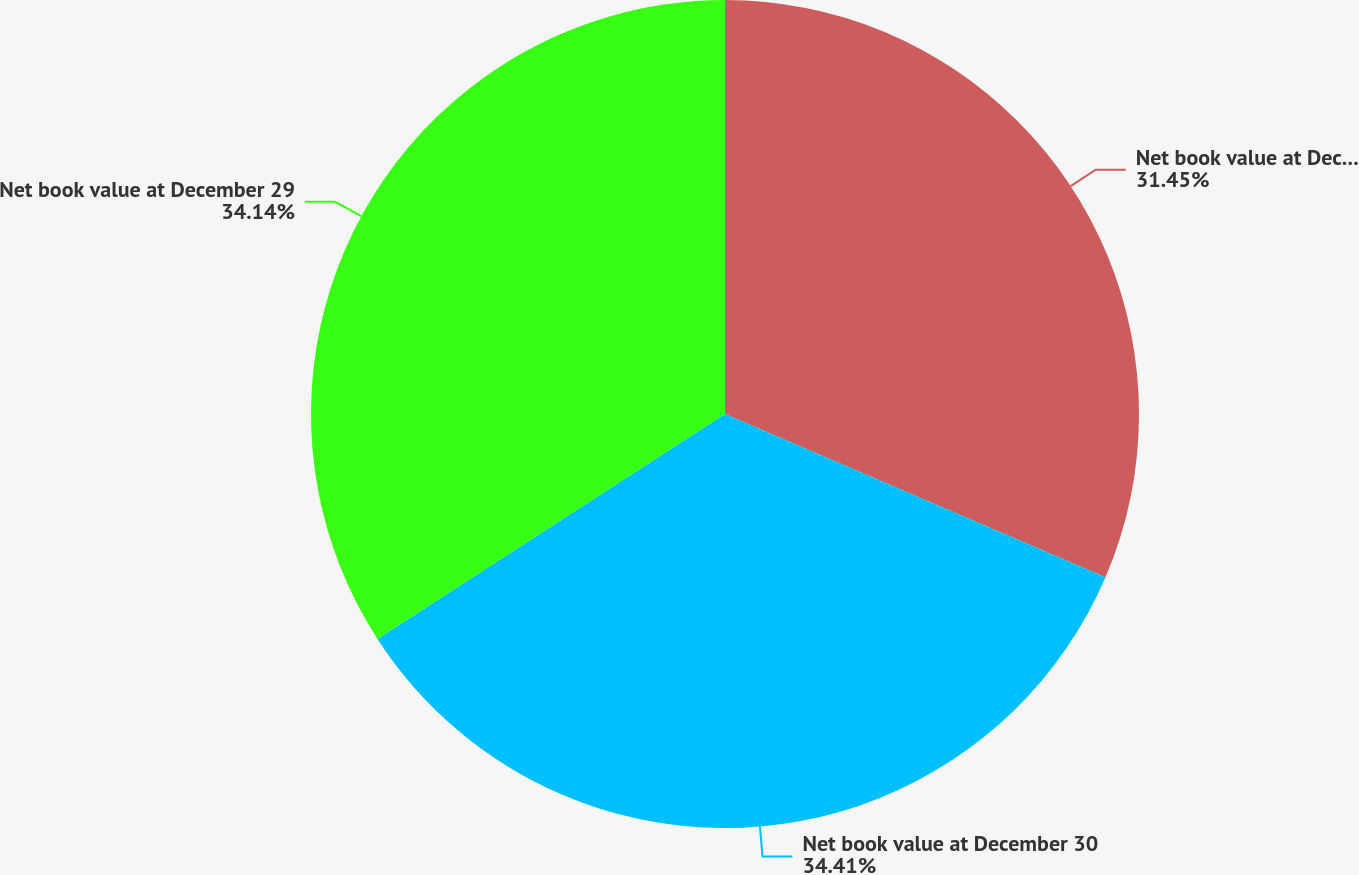Convert chart. <chart><loc_0><loc_0><loc_500><loc_500><pie_chart><fcel>Net book value at December 31<fcel>Net book value at December 30<fcel>Net book value at December 29<nl><fcel>31.45%<fcel>34.41%<fcel>34.14%<nl></chart> 